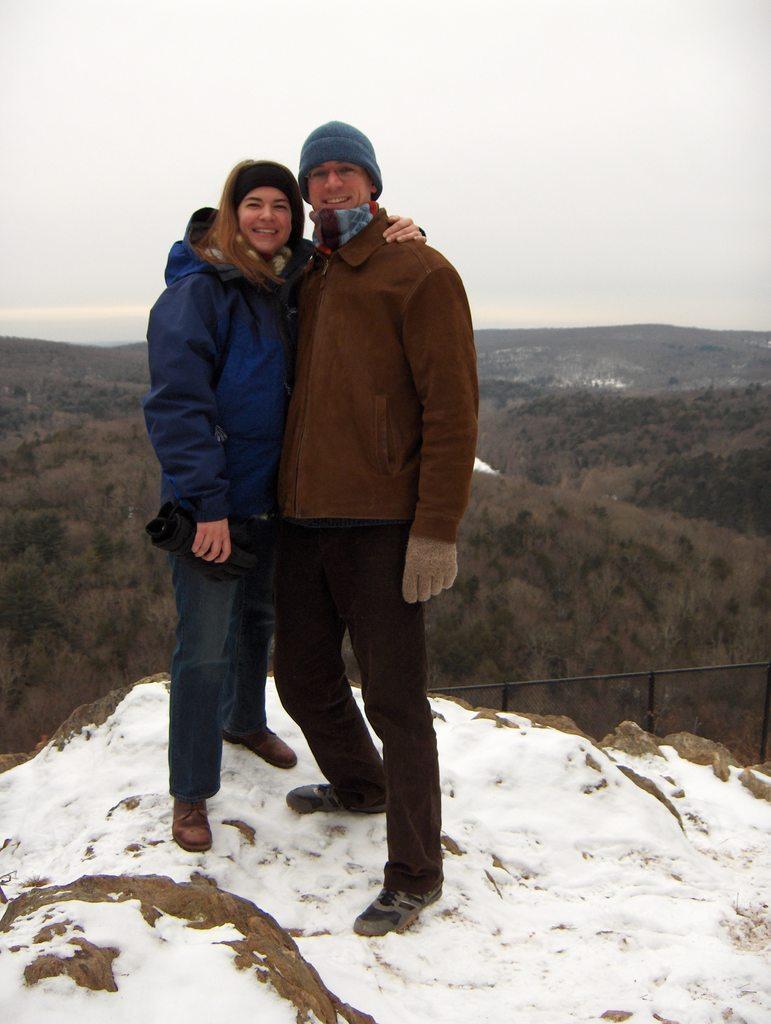Could you give a brief overview of what you see in this image? These two people are smiling and wore jackets. On this surface there is a snow. 